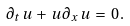<formula> <loc_0><loc_0><loc_500><loc_500>\partial _ { t } \, u \, + \, u \, \partial _ { x } \, u \, = \, 0 \, .</formula> 